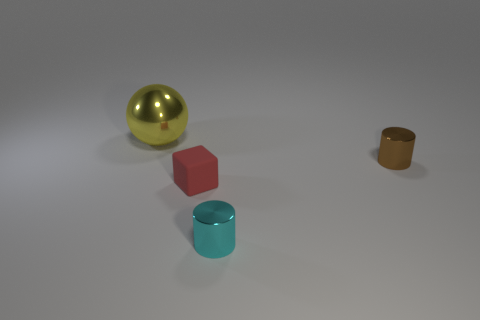Is there any other thing that is made of the same material as the block?
Your response must be concise. No. What color is the shiny thing that is the same size as the cyan cylinder?
Offer a very short reply. Brown. Are there an equal number of tiny brown objects that are in front of the block and brown matte things?
Give a very brief answer. Yes. There is a cylinder behind the metallic cylinder in front of the red rubber block; what color is it?
Keep it short and to the point. Brown. How big is the metallic object that is behind the shiny object on the right side of the cyan metal cylinder?
Make the answer very short. Large. What number of other things are there of the same size as the red rubber cube?
Give a very brief answer. 2. The metallic cylinder that is to the left of the metal cylinder behind the shiny thing in front of the red cube is what color?
Offer a terse response. Cyan. What number of other objects are the same shape as the small matte object?
Give a very brief answer. 0. The red thing that is left of the tiny cyan thing has what shape?
Make the answer very short. Cube. Is there a small cyan metal cylinder on the right side of the small metallic cylinder that is to the right of the small cyan shiny cylinder?
Your response must be concise. No. 